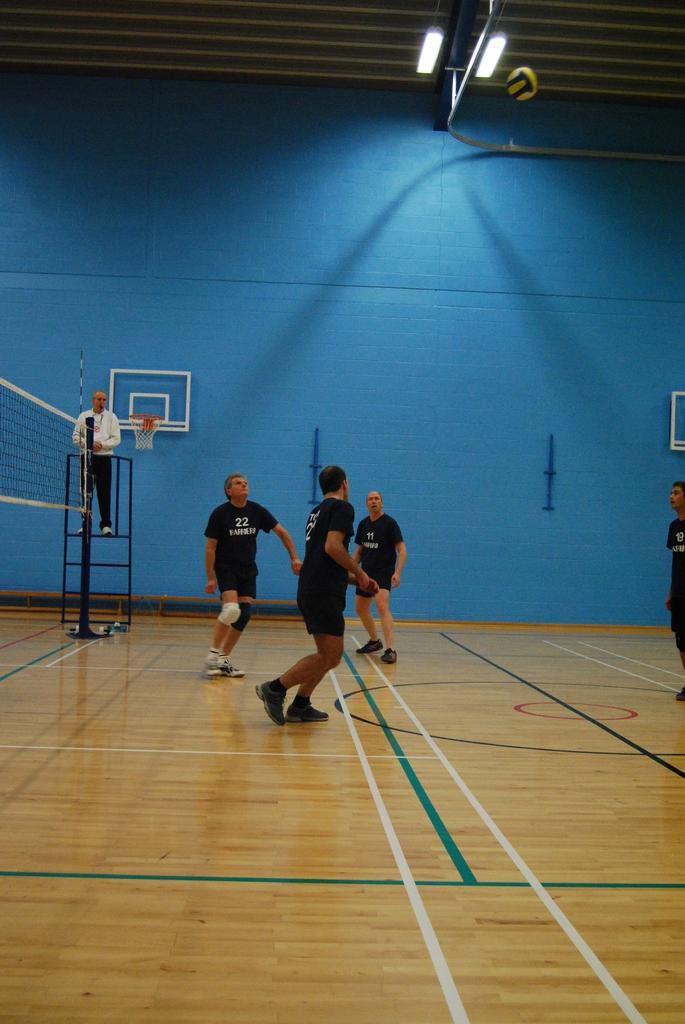What are the people in the image doing on the floor? There are persons on the floor, but the specific activity they are engaged in is not mentioned in the facts. What is the person standing on in the image? The person is standing on a ladder. What is the purpose of the basketball goal in the image? The basketball goal is present in the image, but the purpose or activity related to it is not mentioned in the facts. What is the mesh associated with in the image? There is a mesh associated with the basketball goal in the image. What type of lighting is visible in the image? There are lights visible in the image. What is the background in the image? There is a wall in the image. How many beggars can be seen holding lunch in the image? There are no beggars or lunch present in the image. 